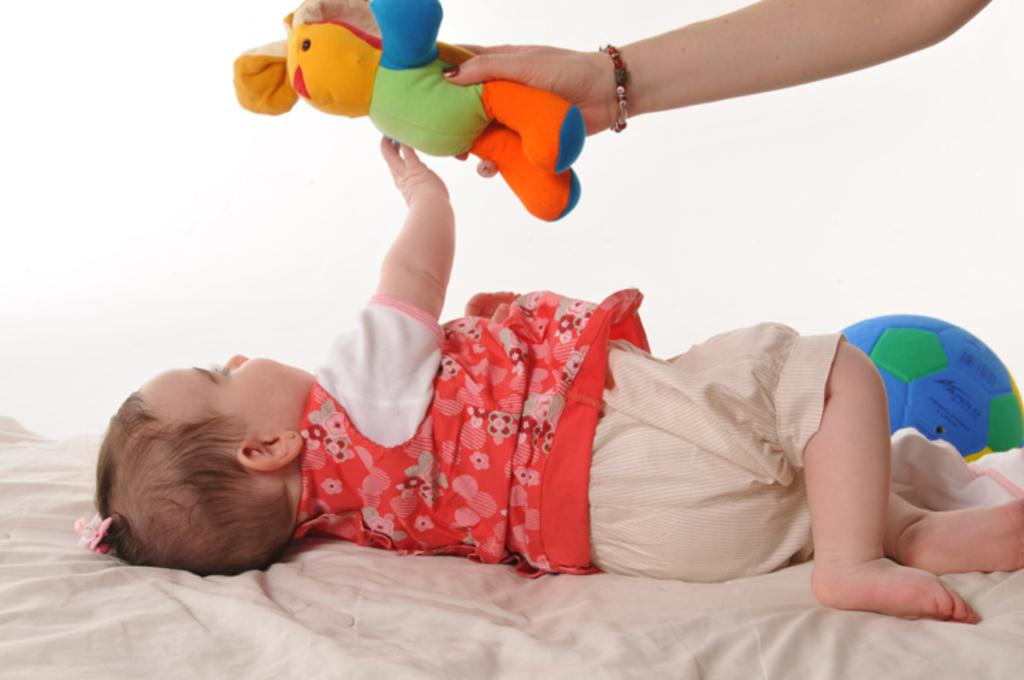What is the main subject of the image? The main subject of the image is a baby. Can you describe the baby's appearance? The baby has a clip in her hair and is wearing a red T-shirt. Where is the baby located in the image? The baby is sleeping on a bed sheet. What can be seen in the background of the image? There is a ball in the background of the image. What is happening with the baby in the image? A hand is holding a toy shown to the baby. What type of produce is being harvested by the actor in the image? There is no actor or produce present in the image; it features a baby sleeping on a bed sheet with a toy being shown to her. 